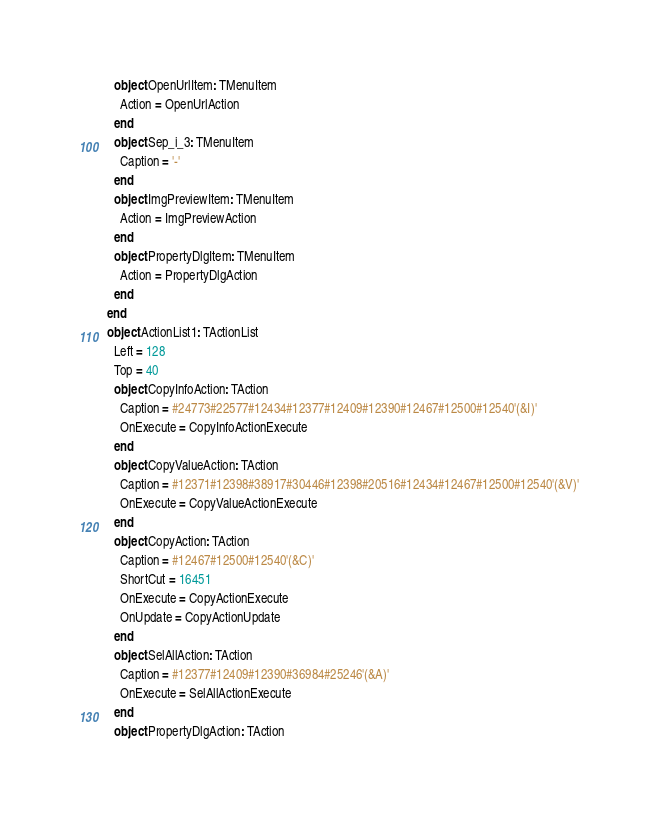<code> <loc_0><loc_0><loc_500><loc_500><_Pascal_>    object OpenUrlItem: TMenuItem
      Action = OpenUrlAction
    end
    object Sep_i_3: TMenuItem
      Caption = '-'
    end
    object ImgPreviewItem: TMenuItem
      Action = ImgPreviewAction
    end
    object PropertyDlgItem: TMenuItem
      Action = PropertyDlgAction
    end
  end
  object ActionList1: TActionList
    Left = 128
    Top = 40
    object CopyInfoAction: TAction
      Caption = #24773#22577#12434#12377#12409#12390#12467#12500#12540'(&I)'
      OnExecute = CopyInfoActionExecute
    end
    object CopyValueAction: TAction
      Caption = #12371#12398#38917#30446#12398#20516#12434#12467#12500#12540'(&V)'
      OnExecute = CopyValueActionExecute
    end
    object CopyAction: TAction
      Caption = #12467#12500#12540'(&C)'
      ShortCut = 16451
      OnExecute = CopyActionExecute
      OnUpdate = CopyActionUpdate
    end
    object SelAllAction: TAction
      Caption = #12377#12409#12390#36984#25246'(&A)'
      OnExecute = SelAllActionExecute
    end
    object PropertyDlgAction: TAction</code> 